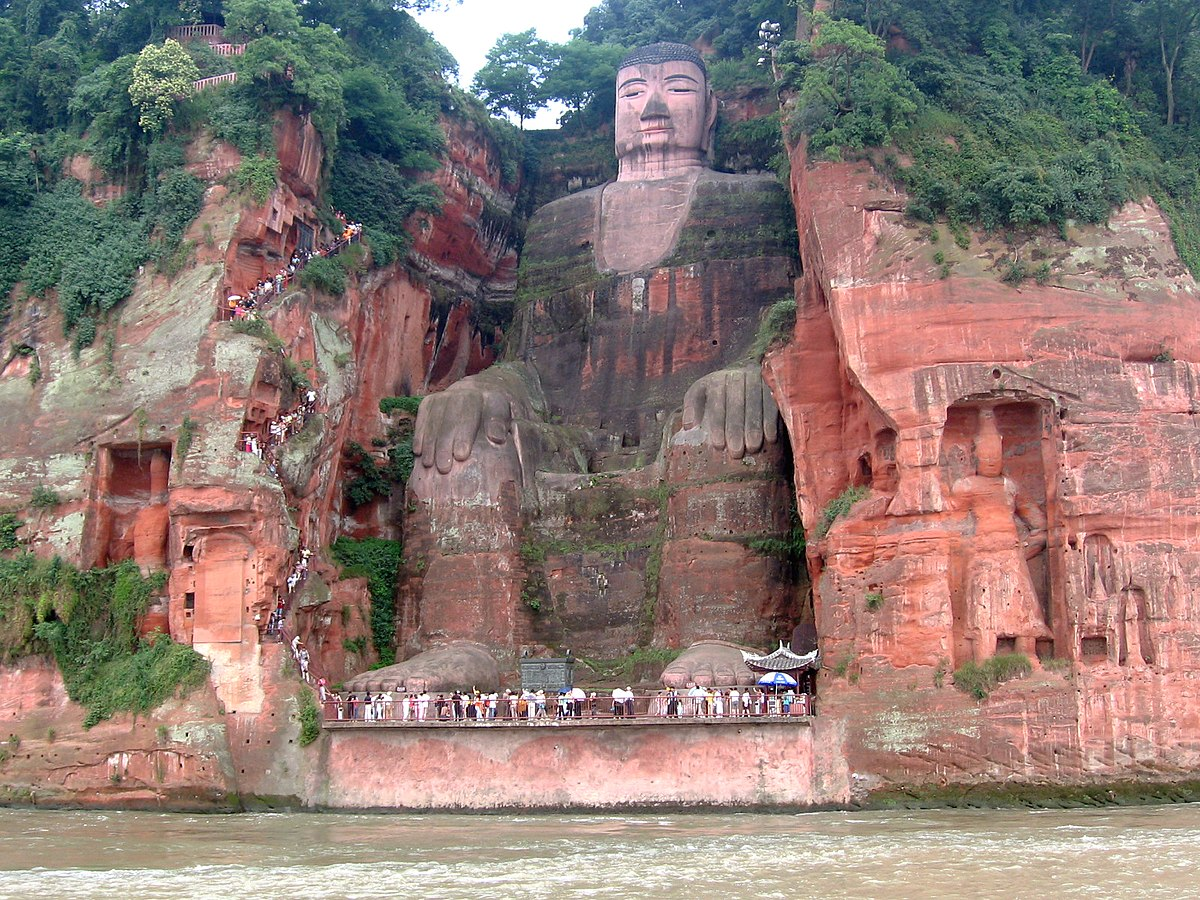How does the Leshan Giant Buddha influence local culture? The Leshan Giant Buddha significantly influences local culture, serving as a focal point for Chinese Buddhist practices and beliefs. It draws pilgrims and monks from across the globe, who come to meditate and seek blessings. Locally, it boosts cultural tourism, underpinning many businesses and services. The presence of this ancient statue also reinforces a sense of pride and identity among the local populace, reminding them of their rich heritage and the historical significance of their region. 